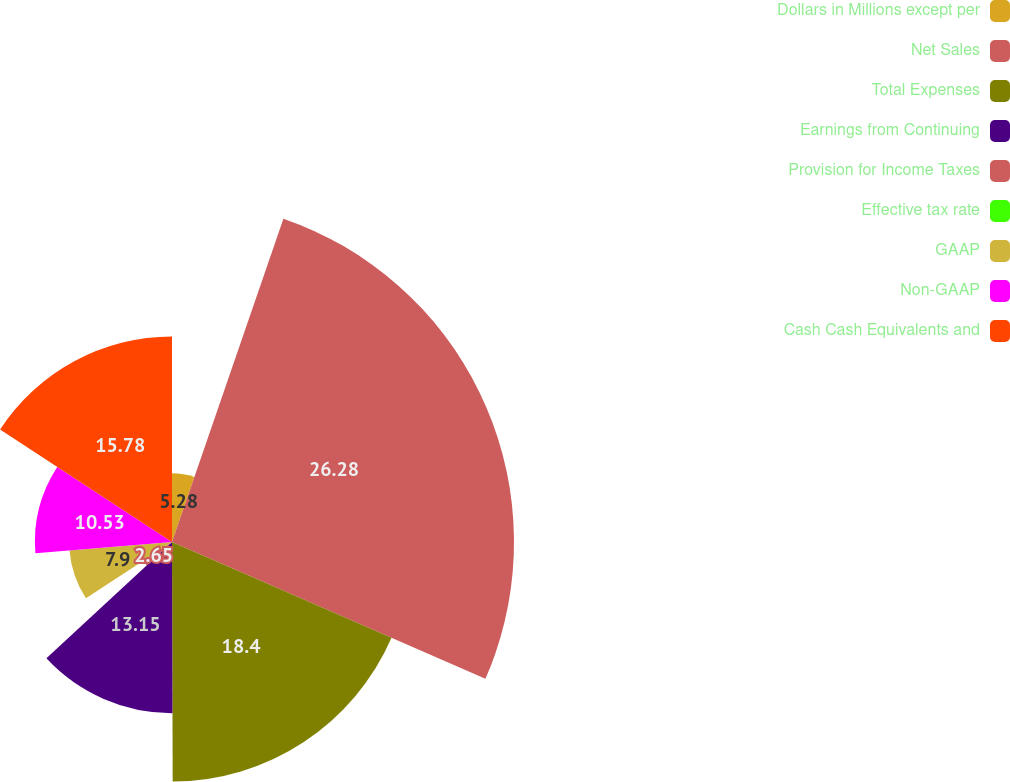Convert chart to OTSL. <chart><loc_0><loc_0><loc_500><loc_500><pie_chart><fcel>Dollars in Millions except per<fcel>Net Sales<fcel>Total Expenses<fcel>Earnings from Continuing<fcel>Provision for Income Taxes<fcel>Effective tax rate<fcel>GAAP<fcel>Non-GAAP<fcel>Cash Cash Equivalents and<nl><fcel>5.28%<fcel>26.27%<fcel>18.4%<fcel>13.15%<fcel>2.65%<fcel>0.03%<fcel>7.9%<fcel>10.53%<fcel>15.78%<nl></chart> 